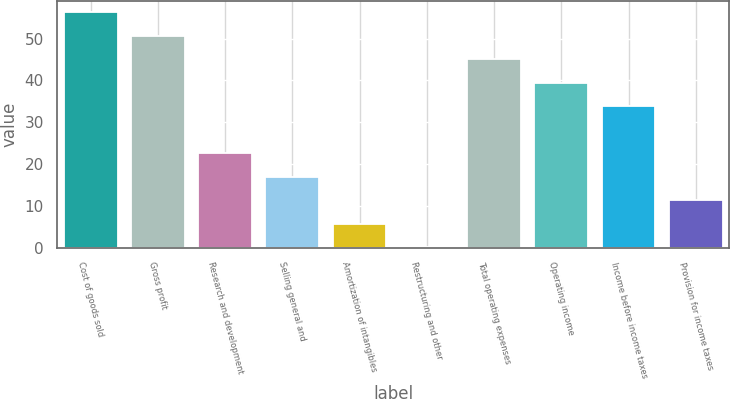Convert chart to OTSL. <chart><loc_0><loc_0><loc_500><loc_500><bar_chart><fcel>Cost of goods sold<fcel>Gross profit<fcel>Research and development<fcel>Selling general and<fcel>Amortization of intangibles<fcel>Restructuring and other<fcel>Total operating expenses<fcel>Operating income<fcel>Income before income taxes<fcel>Provision for income taxes<nl><fcel>56.3<fcel>50.68<fcel>22.58<fcel>16.96<fcel>5.72<fcel>0.1<fcel>45.06<fcel>39.44<fcel>33.82<fcel>11.34<nl></chart> 